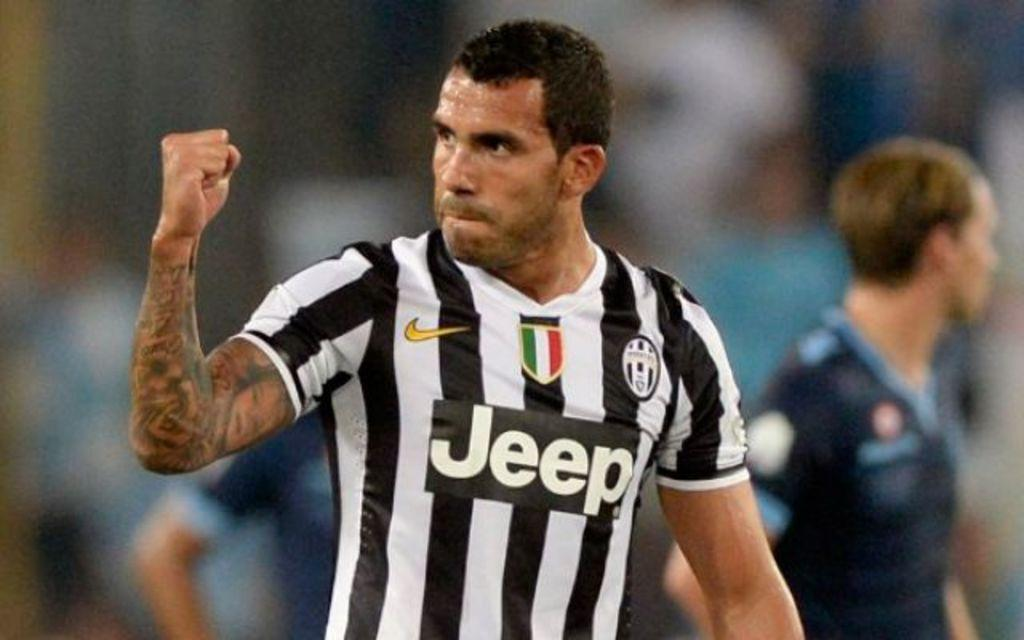<image>
Relay a brief, clear account of the picture shown. men playing a game of soccer together with jeep written on jersey 